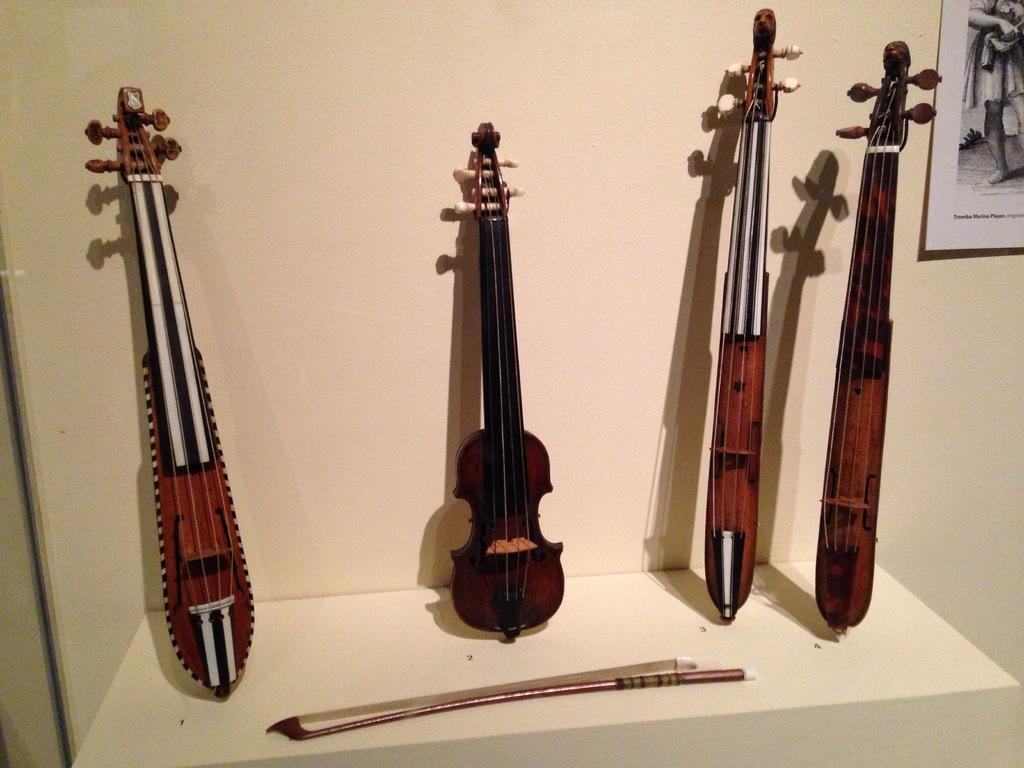Please provide a concise description of this image. In this picture we can see a violin and few other musical instruments on the table, in the background we can see a poster on the wall. 